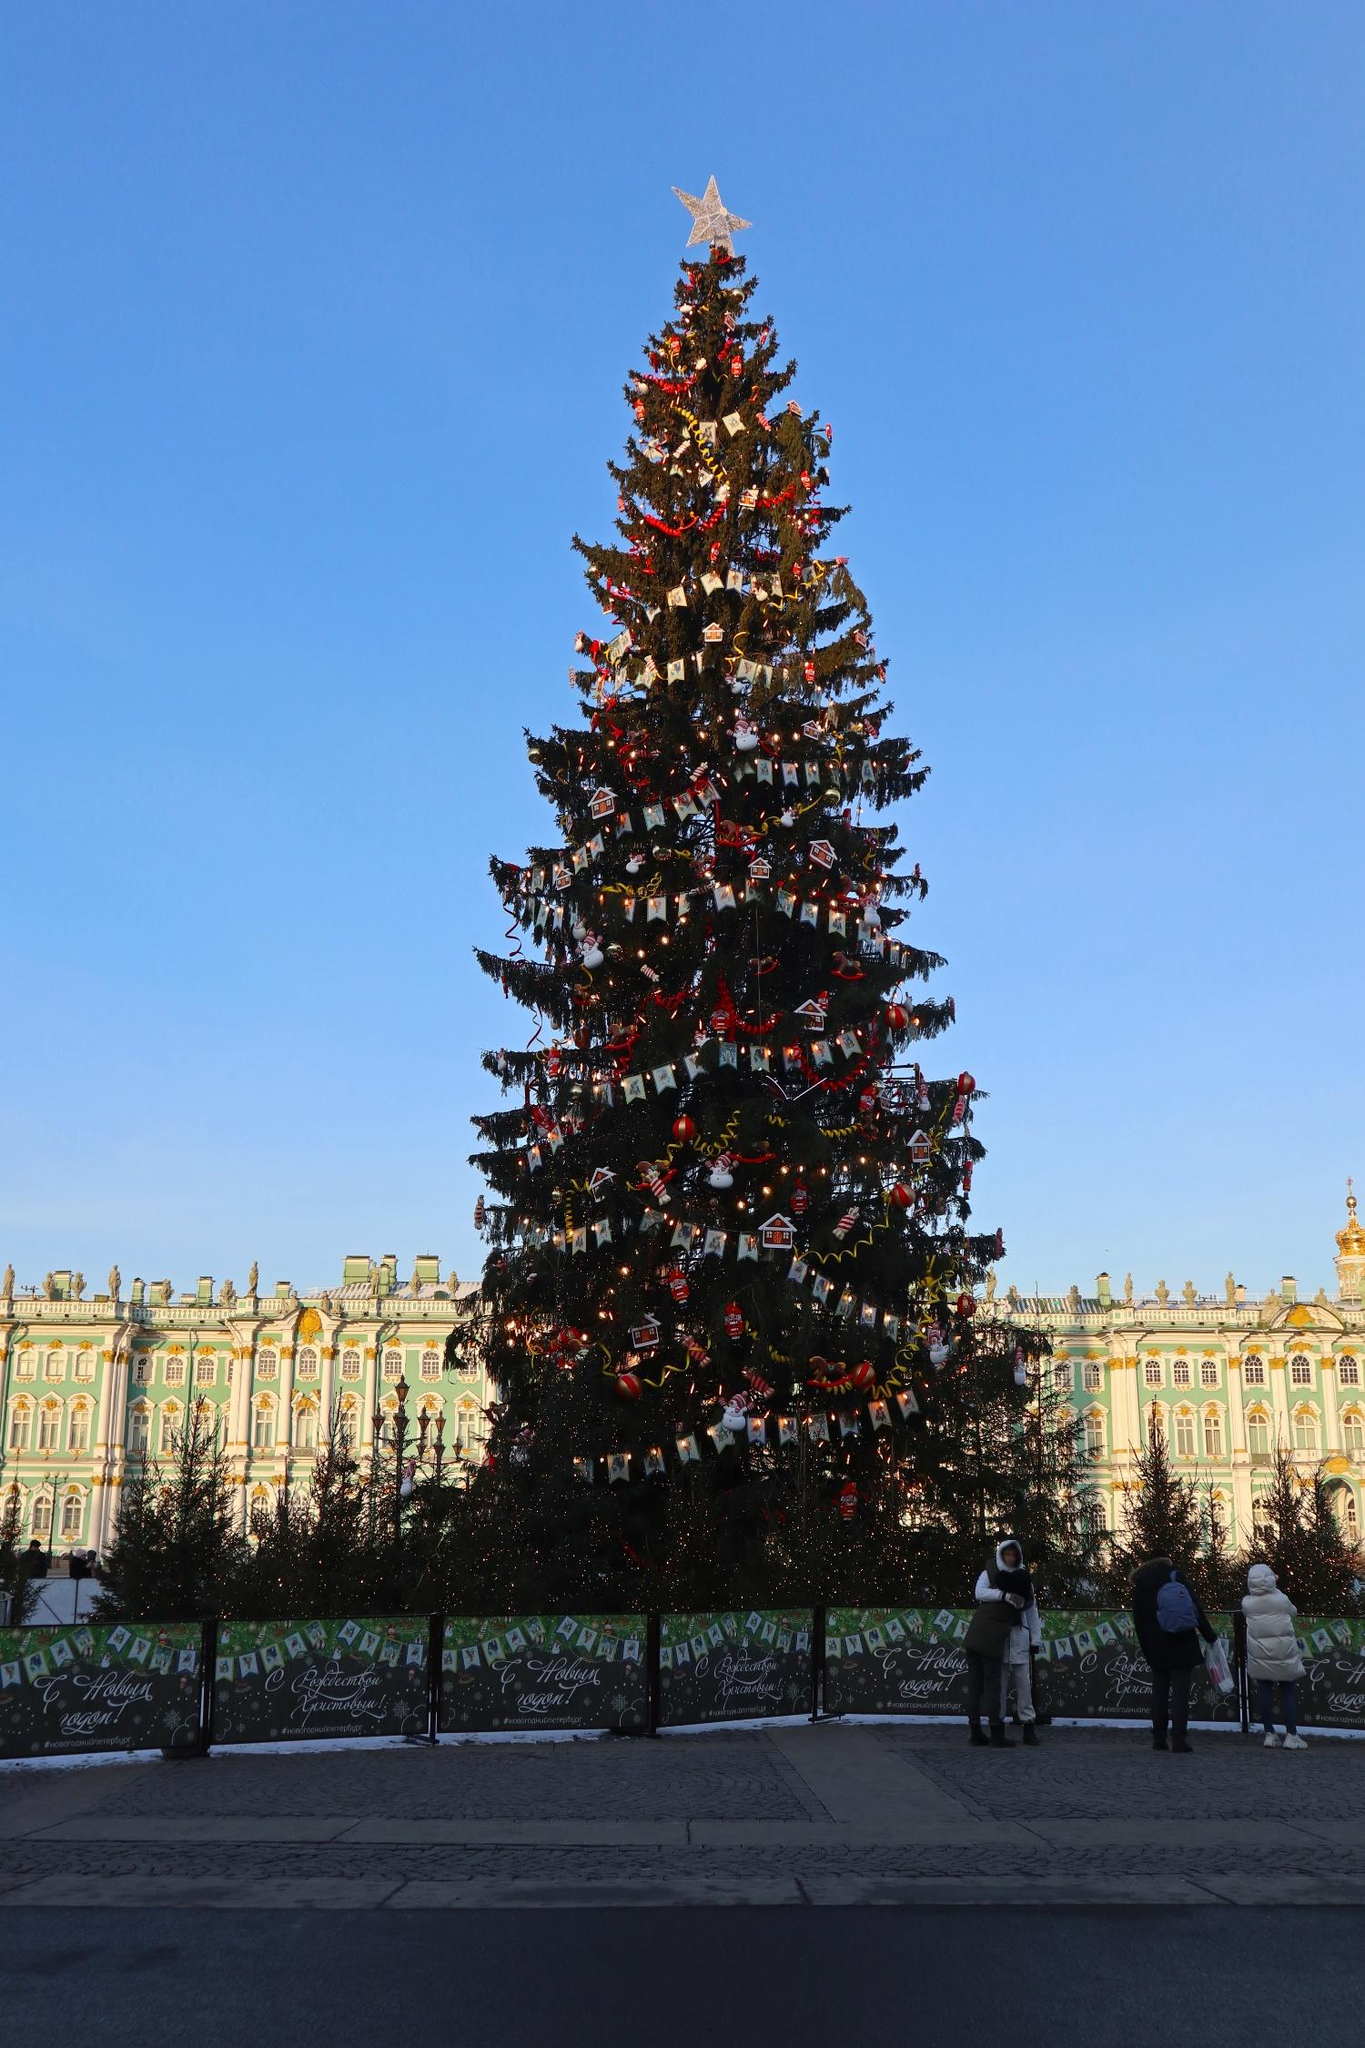Imagine you are one of the ornaments on the tree. Describe your experience. As an ornament hanging on this majestic Christmas tree, I am granted a unique vantage point of the festive surroundings. I sway gently in the winter breeze, feeling the cool air against my surface. The twinkling lights around me create a warm glow, making me sparkle even brighter. From my position, I can see the delight in people’s faces as they gaze up at the tree. Each day, I become part of countless photographs, capturing cherished memories for families and friends. The harmony of the decorations around me and the grandeur of the setting remind me of the joy and magic that this season brings to everyone. 